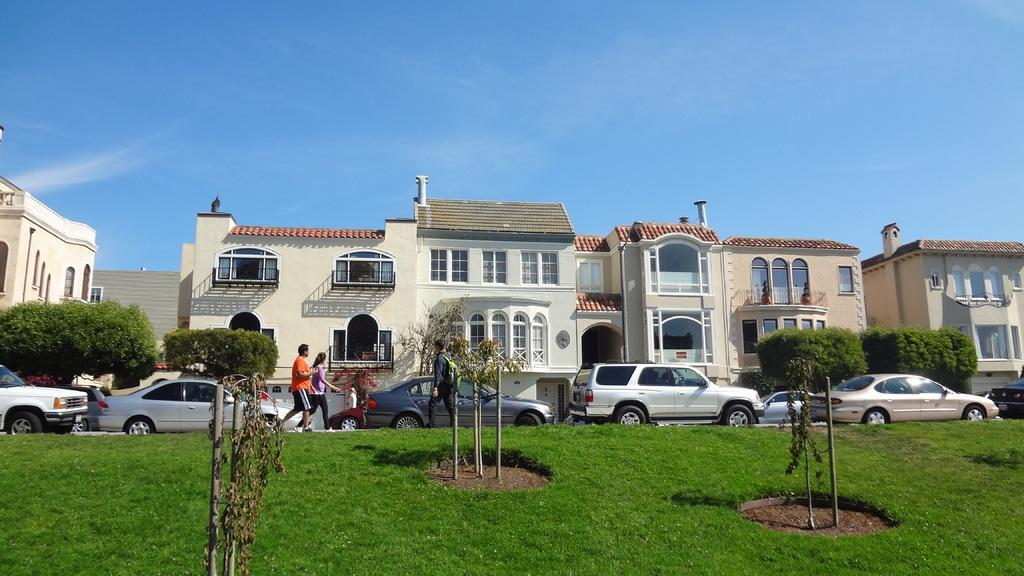What can be seen on the road in the image? There are vehicles on the road in the image. Who or what else is present in the image? There are people in the image. What can be seen in the distance in the image? There are buildings visible in the background of the image. What type of vegetation is present in the image? Trees, plants, and grass are present in the image. Where are the dolls placed in the image? There are no dolls present in the image. What type of roof can be seen on the basin in the image? There is no basin or roof present in the image. 